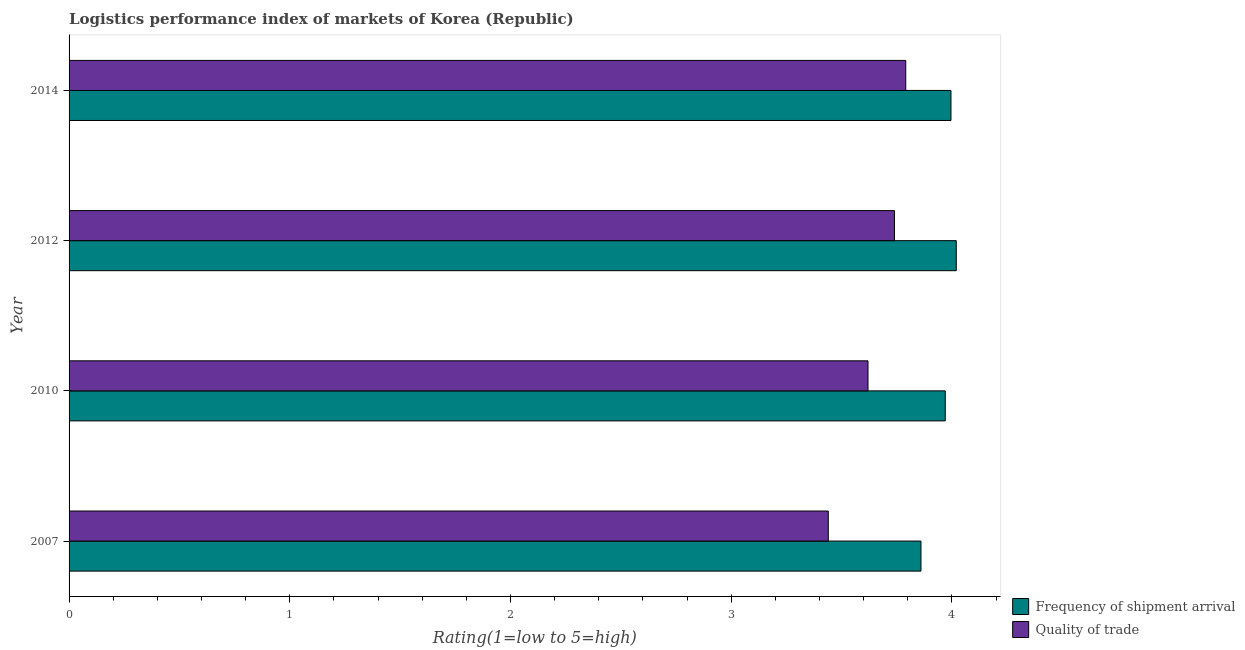How many different coloured bars are there?
Offer a terse response. 2. How many bars are there on the 4th tick from the bottom?
Your answer should be very brief. 2. What is the label of the 3rd group of bars from the top?
Provide a short and direct response. 2010. What is the lpi quality of trade in 2012?
Provide a succinct answer. 3.74. Across all years, what is the maximum lpi of frequency of shipment arrival?
Provide a succinct answer. 4.02. Across all years, what is the minimum lpi of frequency of shipment arrival?
Your response must be concise. 3.86. In which year was the lpi quality of trade maximum?
Provide a short and direct response. 2014. What is the total lpi of frequency of shipment arrival in the graph?
Give a very brief answer. 15.85. What is the difference between the lpi of frequency of shipment arrival in 2012 and that in 2014?
Provide a succinct answer. 0.02. What is the difference between the lpi quality of trade in 2010 and the lpi of frequency of shipment arrival in 2007?
Keep it short and to the point. -0.24. What is the average lpi quality of trade per year?
Your answer should be very brief. 3.65. In the year 2007, what is the difference between the lpi of frequency of shipment arrival and lpi quality of trade?
Offer a terse response. 0.42. In how many years, is the lpi quality of trade greater than 0.6000000000000001 ?
Keep it short and to the point. 4. What is the ratio of the lpi of frequency of shipment arrival in 2007 to that in 2014?
Your answer should be compact. 0.97. Is the lpi of frequency of shipment arrival in 2012 less than that in 2014?
Keep it short and to the point. No. What is the difference between the highest and the second highest lpi quality of trade?
Keep it short and to the point. 0.05. In how many years, is the lpi of frequency of shipment arrival greater than the average lpi of frequency of shipment arrival taken over all years?
Make the answer very short. 3. What does the 2nd bar from the top in 2014 represents?
Make the answer very short. Frequency of shipment arrival. What does the 2nd bar from the bottom in 2012 represents?
Offer a very short reply. Quality of trade. How many bars are there?
Your answer should be very brief. 8. How many years are there in the graph?
Make the answer very short. 4. What is the difference between two consecutive major ticks on the X-axis?
Your answer should be very brief. 1. Are the values on the major ticks of X-axis written in scientific E-notation?
Provide a short and direct response. No. How many legend labels are there?
Ensure brevity in your answer.  2. How are the legend labels stacked?
Your answer should be compact. Vertical. What is the title of the graph?
Your answer should be very brief. Logistics performance index of markets of Korea (Republic). What is the label or title of the X-axis?
Keep it short and to the point. Rating(1=low to 5=high). What is the Rating(1=low to 5=high) of Frequency of shipment arrival in 2007?
Provide a succinct answer. 3.86. What is the Rating(1=low to 5=high) of Quality of trade in 2007?
Offer a terse response. 3.44. What is the Rating(1=low to 5=high) in Frequency of shipment arrival in 2010?
Keep it short and to the point. 3.97. What is the Rating(1=low to 5=high) in Quality of trade in 2010?
Provide a short and direct response. 3.62. What is the Rating(1=low to 5=high) in Frequency of shipment arrival in 2012?
Provide a short and direct response. 4.02. What is the Rating(1=low to 5=high) in Quality of trade in 2012?
Provide a succinct answer. 3.74. What is the Rating(1=low to 5=high) in Frequency of shipment arrival in 2014?
Make the answer very short. 4. What is the Rating(1=low to 5=high) of Quality of trade in 2014?
Give a very brief answer. 3.79. Across all years, what is the maximum Rating(1=low to 5=high) in Frequency of shipment arrival?
Your response must be concise. 4.02. Across all years, what is the maximum Rating(1=low to 5=high) of Quality of trade?
Provide a succinct answer. 3.79. Across all years, what is the minimum Rating(1=low to 5=high) of Frequency of shipment arrival?
Keep it short and to the point. 3.86. Across all years, what is the minimum Rating(1=low to 5=high) of Quality of trade?
Your answer should be compact. 3.44. What is the total Rating(1=low to 5=high) of Frequency of shipment arrival in the graph?
Provide a short and direct response. 15.85. What is the total Rating(1=low to 5=high) of Quality of trade in the graph?
Your answer should be compact. 14.59. What is the difference between the Rating(1=low to 5=high) of Frequency of shipment arrival in 2007 and that in 2010?
Provide a succinct answer. -0.11. What is the difference between the Rating(1=low to 5=high) of Quality of trade in 2007 and that in 2010?
Give a very brief answer. -0.18. What is the difference between the Rating(1=low to 5=high) in Frequency of shipment arrival in 2007 and that in 2012?
Make the answer very short. -0.16. What is the difference between the Rating(1=low to 5=high) of Frequency of shipment arrival in 2007 and that in 2014?
Provide a succinct answer. -0.14. What is the difference between the Rating(1=low to 5=high) of Quality of trade in 2007 and that in 2014?
Provide a short and direct response. -0.35. What is the difference between the Rating(1=low to 5=high) of Frequency of shipment arrival in 2010 and that in 2012?
Ensure brevity in your answer.  -0.05. What is the difference between the Rating(1=low to 5=high) in Quality of trade in 2010 and that in 2012?
Offer a very short reply. -0.12. What is the difference between the Rating(1=low to 5=high) of Frequency of shipment arrival in 2010 and that in 2014?
Provide a short and direct response. -0.03. What is the difference between the Rating(1=low to 5=high) of Quality of trade in 2010 and that in 2014?
Make the answer very short. -0.17. What is the difference between the Rating(1=low to 5=high) of Frequency of shipment arrival in 2012 and that in 2014?
Keep it short and to the point. 0.02. What is the difference between the Rating(1=low to 5=high) of Quality of trade in 2012 and that in 2014?
Your answer should be compact. -0.05. What is the difference between the Rating(1=low to 5=high) in Frequency of shipment arrival in 2007 and the Rating(1=low to 5=high) in Quality of trade in 2010?
Ensure brevity in your answer.  0.24. What is the difference between the Rating(1=low to 5=high) in Frequency of shipment arrival in 2007 and the Rating(1=low to 5=high) in Quality of trade in 2012?
Make the answer very short. 0.12. What is the difference between the Rating(1=low to 5=high) of Frequency of shipment arrival in 2007 and the Rating(1=low to 5=high) of Quality of trade in 2014?
Make the answer very short. 0.07. What is the difference between the Rating(1=low to 5=high) of Frequency of shipment arrival in 2010 and the Rating(1=low to 5=high) of Quality of trade in 2012?
Make the answer very short. 0.23. What is the difference between the Rating(1=low to 5=high) of Frequency of shipment arrival in 2010 and the Rating(1=low to 5=high) of Quality of trade in 2014?
Make the answer very short. 0.18. What is the difference between the Rating(1=low to 5=high) of Frequency of shipment arrival in 2012 and the Rating(1=low to 5=high) of Quality of trade in 2014?
Provide a succinct answer. 0.23. What is the average Rating(1=low to 5=high) in Frequency of shipment arrival per year?
Provide a short and direct response. 3.96. What is the average Rating(1=low to 5=high) in Quality of trade per year?
Your answer should be very brief. 3.65. In the year 2007, what is the difference between the Rating(1=low to 5=high) in Frequency of shipment arrival and Rating(1=low to 5=high) in Quality of trade?
Provide a short and direct response. 0.42. In the year 2010, what is the difference between the Rating(1=low to 5=high) in Frequency of shipment arrival and Rating(1=low to 5=high) in Quality of trade?
Ensure brevity in your answer.  0.35. In the year 2012, what is the difference between the Rating(1=low to 5=high) in Frequency of shipment arrival and Rating(1=low to 5=high) in Quality of trade?
Provide a succinct answer. 0.28. In the year 2014, what is the difference between the Rating(1=low to 5=high) in Frequency of shipment arrival and Rating(1=low to 5=high) in Quality of trade?
Your answer should be compact. 0.2. What is the ratio of the Rating(1=low to 5=high) of Frequency of shipment arrival in 2007 to that in 2010?
Make the answer very short. 0.97. What is the ratio of the Rating(1=low to 5=high) of Quality of trade in 2007 to that in 2010?
Offer a terse response. 0.95. What is the ratio of the Rating(1=low to 5=high) of Frequency of shipment arrival in 2007 to that in 2012?
Your response must be concise. 0.96. What is the ratio of the Rating(1=low to 5=high) in Quality of trade in 2007 to that in 2012?
Offer a very short reply. 0.92. What is the ratio of the Rating(1=low to 5=high) in Frequency of shipment arrival in 2007 to that in 2014?
Your response must be concise. 0.97. What is the ratio of the Rating(1=low to 5=high) in Quality of trade in 2007 to that in 2014?
Your answer should be compact. 0.91. What is the ratio of the Rating(1=low to 5=high) in Frequency of shipment arrival in 2010 to that in 2012?
Offer a very short reply. 0.99. What is the ratio of the Rating(1=low to 5=high) of Quality of trade in 2010 to that in 2012?
Offer a very short reply. 0.97. What is the ratio of the Rating(1=low to 5=high) of Quality of trade in 2010 to that in 2014?
Give a very brief answer. 0.95. What is the ratio of the Rating(1=low to 5=high) in Frequency of shipment arrival in 2012 to that in 2014?
Offer a terse response. 1.01. What is the ratio of the Rating(1=low to 5=high) in Quality of trade in 2012 to that in 2014?
Provide a succinct answer. 0.99. What is the difference between the highest and the second highest Rating(1=low to 5=high) of Frequency of shipment arrival?
Make the answer very short. 0.02. What is the difference between the highest and the second highest Rating(1=low to 5=high) of Quality of trade?
Ensure brevity in your answer.  0.05. What is the difference between the highest and the lowest Rating(1=low to 5=high) in Frequency of shipment arrival?
Your answer should be very brief. 0.16. What is the difference between the highest and the lowest Rating(1=low to 5=high) in Quality of trade?
Offer a very short reply. 0.35. 